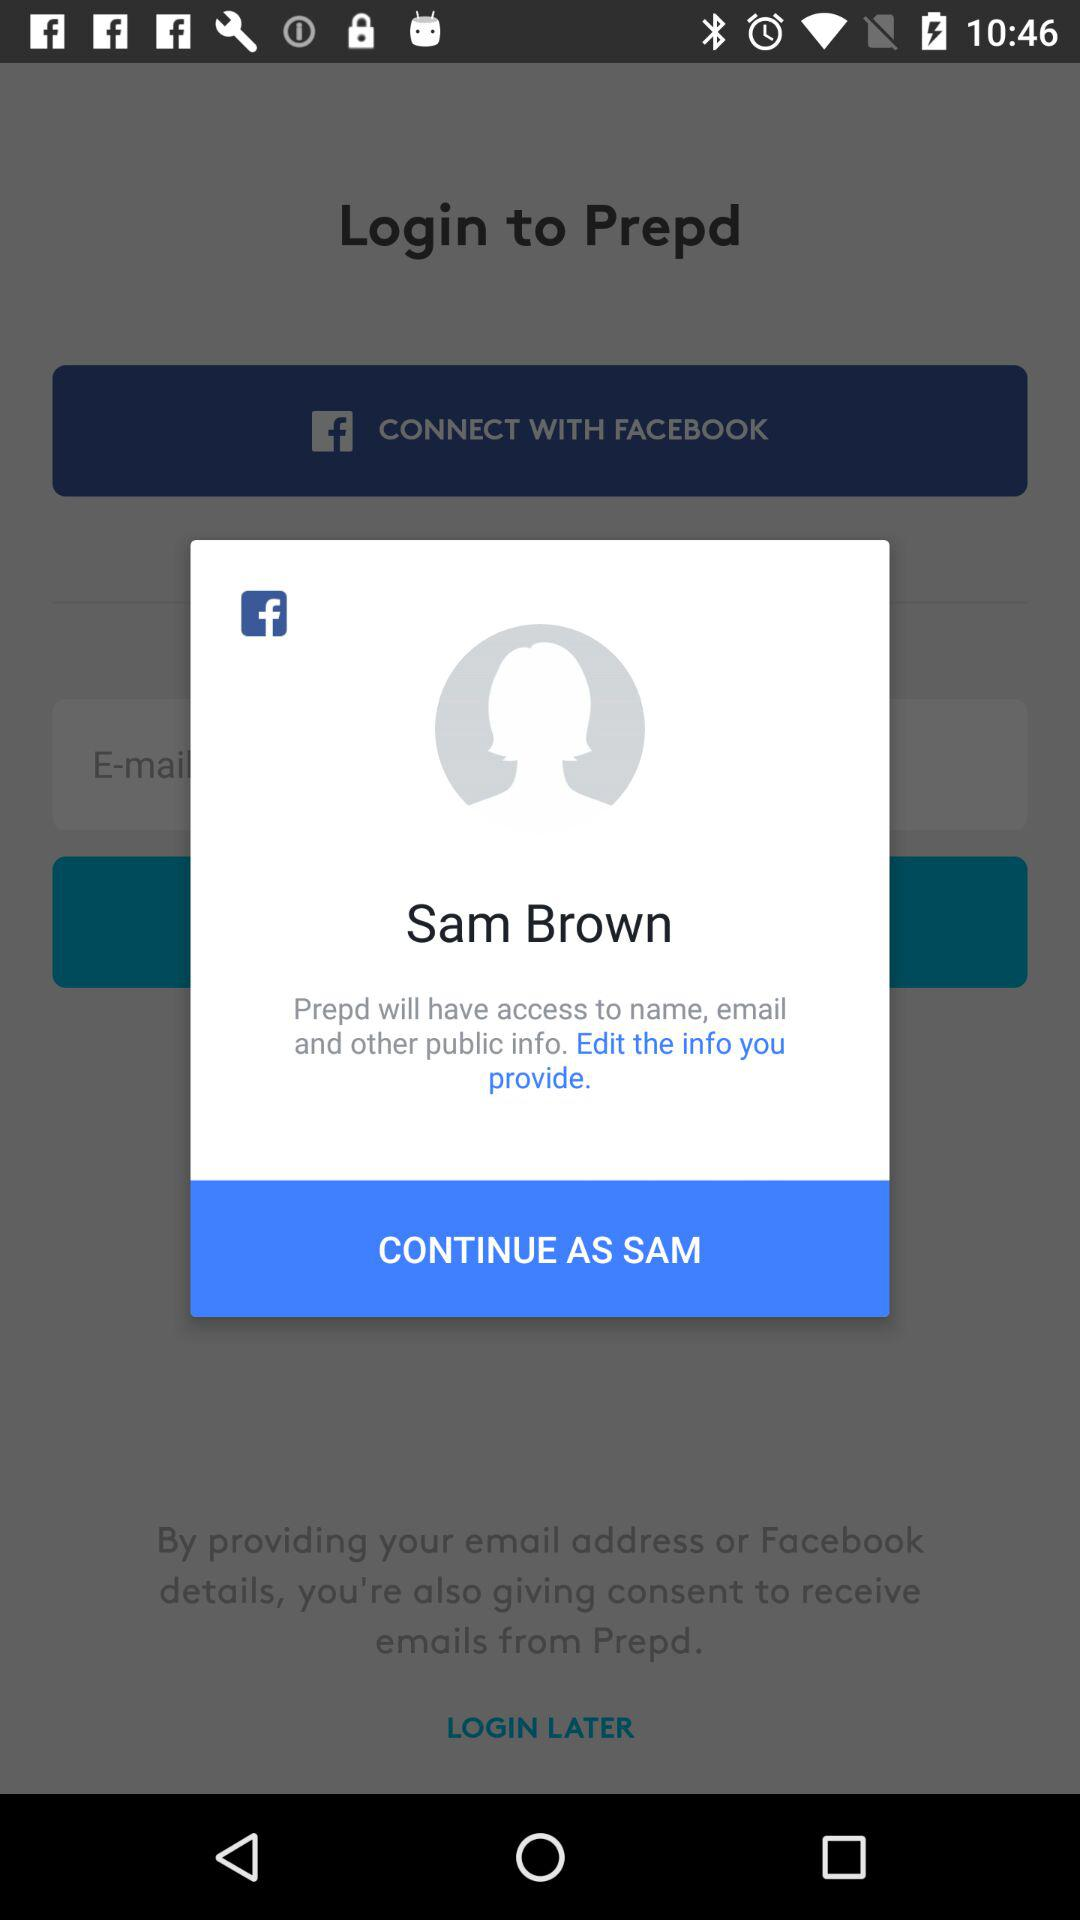What is the name of the user? The name of the user is "Sam Brown". 